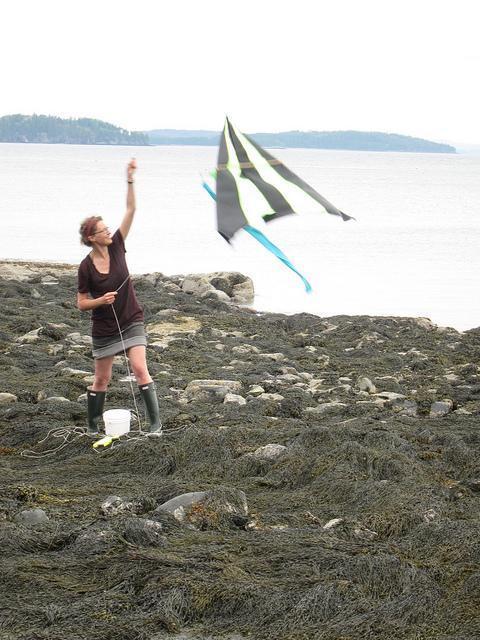How many people are in the picture?
Give a very brief answer. 1. 